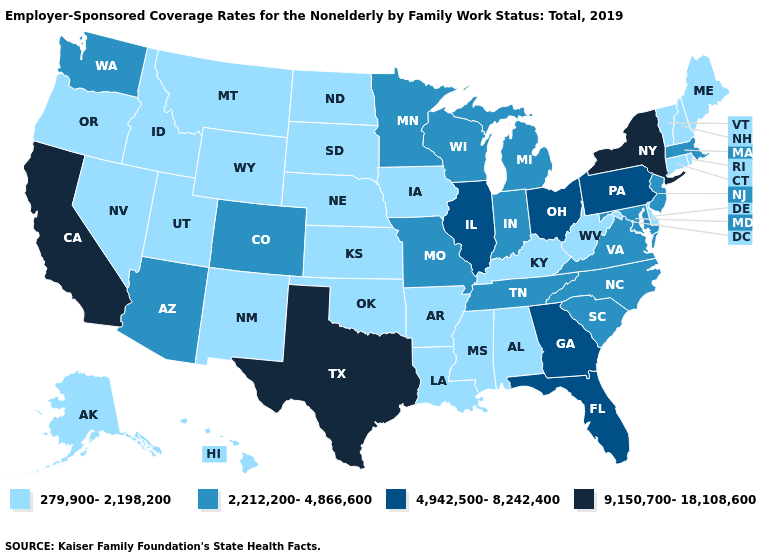Does Minnesota have a lower value than Connecticut?
Give a very brief answer. No. Does Texas have the highest value in the USA?
Give a very brief answer. Yes. Which states hav the highest value in the Northeast?
Concise answer only. New York. Does the first symbol in the legend represent the smallest category?
Be succinct. Yes. Does the map have missing data?
Keep it brief. No. What is the highest value in states that border Illinois?
Quick response, please. 2,212,200-4,866,600. Name the states that have a value in the range 4,942,500-8,242,400?
Quick response, please. Florida, Georgia, Illinois, Ohio, Pennsylvania. Name the states that have a value in the range 4,942,500-8,242,400?
Concise answer only. Florida, Georgia, Illinois, Ohio, Pennsylvania. What is the value of Virginia?
Concise answer only. 2,212,200-4,866,600. Does Minnesota have a higher value than Louisiana?
Keep it brief. Yes. Name the states that have a value in the range 9,150,700-18,108,600?
Keep it brief. California, New York, Texas. Does the first symbol in the legend represent the smallest category?
Be succinct. Yes. Name the states that have a value in the range 2,212,200-4,866,600?
Write a very short answer. Arizona, Colorado, Indiana, Maryland, Massachusetts, Michigan, Minnesota, Missouri, New Jersey, North Carolina, South Carolina, Tennessee, Virginia, Washington, Wisconsin. What is the value of Vermont?
Concise answer only. 279,900-2,198,200. Name the states that have a value in the range 279,900-2,198,200?
Keep it brief. Alabama, Alaska, Arkansas, Connecticut, Delaware, Hawaii, Idaho, Iowa, Kansas, Kentucky, Louisiana, Maine, Mississippi, Montana, Nebraska, Nevada, New Hampshire, New Mexico, North Dakota, Oklahoma, Oregon, Rhode Island, South Dakota, Utah, Vermont, West Virginia, Wyoming. 